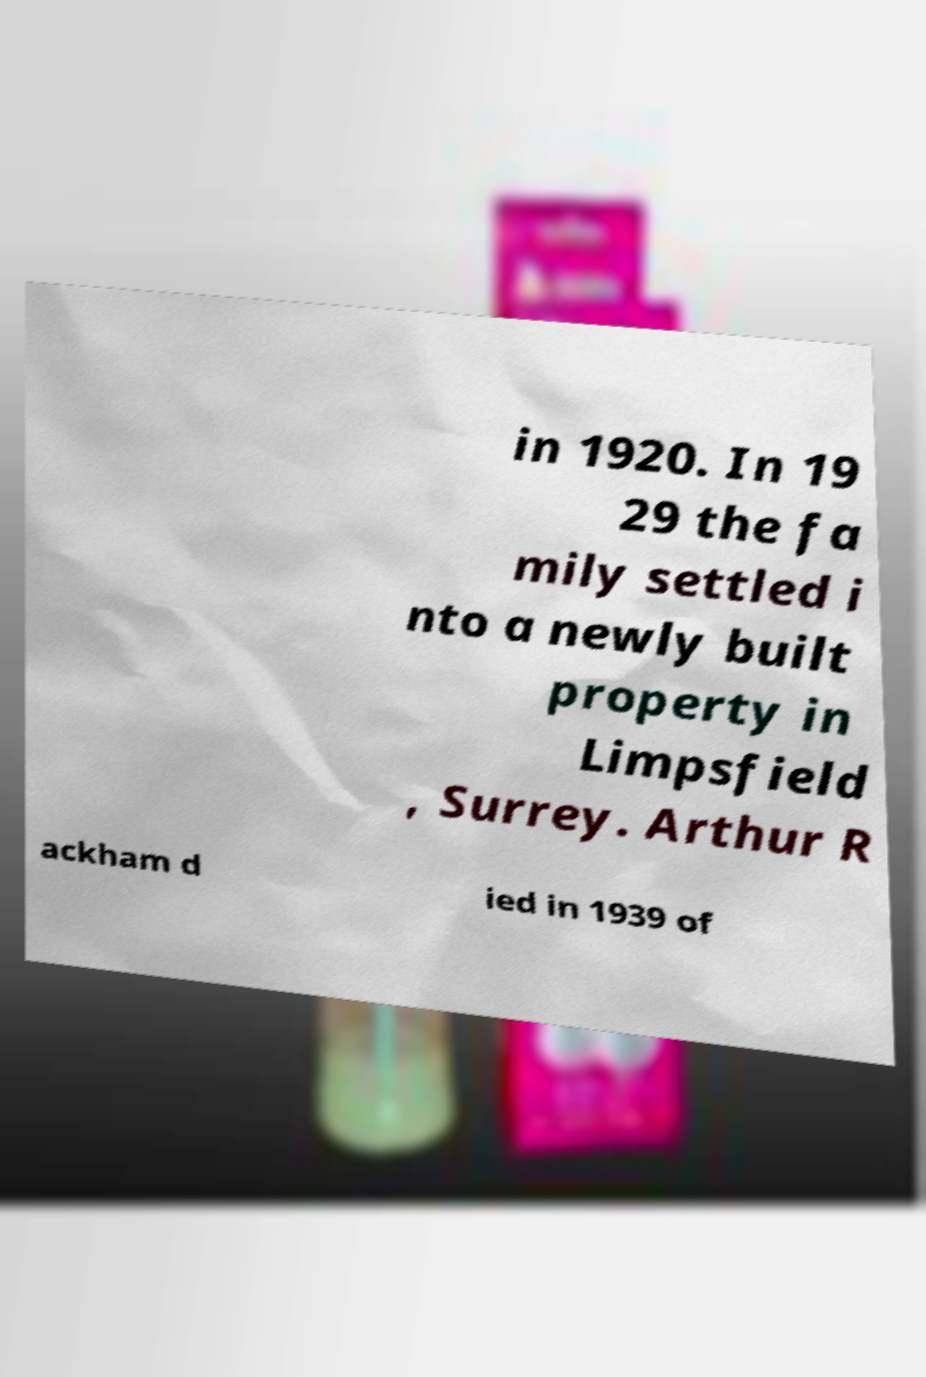Please read and relay the text visible in this image. What does it say? in 1920. In 19 29 the fa mily settled i nto a newly built property in Limpsfield , Surrey. Arthur R ackham d ied in 1939 of 